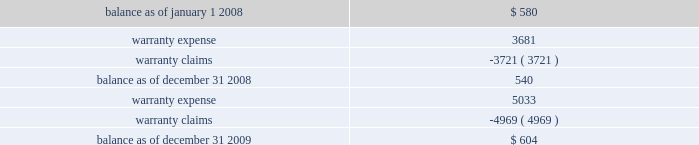Investments prior to our acquisition of keystone on october 12 , 2007 , we held common shares of keystone , which were classified as an available-for-sale investment security .
Accordingly , the investment was included in other assets at its fair value , with the unrealized gain excluded from earnings and included in accumulated other comprehensive income , net of applicable taxes .
Upon our acquisition of keystone on october 12 , 2007 , the unrealized gain was removed from accumulated other comprehensive income , net of applicable taxes , and the original cost of the common shares was considered a component of the purchase price .
Fair value of financial instruments our debt is reflected on the balance sheet at cost .
Based on current market conditions , our interest rate margins are below the rate available in the market , which causes the fair value of our debt to fall below the carrying value .
The fair value of our term loans ( see note 6 , 201clong-term obligations 201d ) is approximately $ 570 million at december 31 , 2009 , as compared to the carrying value of $ 596 million .
We estimated the fair value of our term loans by calculating the upfront cash payment a market participant would require to assume our obligations .
The upfront cash payment , excluding any issuance costs , is the amount that a market participant would be able to lend at december 31 , 2009 to an entity with a credit rating similar to ours and achieve sufficient cash inflows to cover the scheduled cash outflows under our term loans .
The carrying amounts of our cash and equivalents , net trade receivables and accounts payable approximate fair value .
We apply the market approach to value our financial assets and liabilities , which include the cash surrender value of life insurance , deferred compensation liabilities and interest rate swaps .
The market approach utilizes available market information to estimate fair value .
Required fair value disclosures are included in note 8 , 201cfair value measurements . 201d accrued expenses we self-insure a portion of employee medical benefits under the terms of our employee health insurance program .
We purchase certain stop-loss insurance to limit our liability exposure .
We also self-insure a portion of our property and casualty risk , which includes automobile liability , general liability , workers 2019 compensation and property under deductible insurance programs .
The insurance premium costs are expensed over the contract periods .
A reserve for liabilities associated with these losses is established for claims filed and claims incurred but not yet reported based upon our estimate of ultimate cost , which is calculated using analyses of historical data .
We monitor new claims and claim development as well as trends related to the claims incurred but not reported in order to assess the adequacy of our insurance reserves .
Self-insurance reserves on the consolidated balance sheets are net of claims deposits of $ 0.7 million and $ 0.8 million , at december 31 , 2009 and 2008 , respectively .
While we do not expect the amounts ultimately paid to differ significantly from our estimates , our insurance reserves and corresponding expenses could be affected if future claim experience differs significantly from historical trends and assumptions .
Product warranties some of our mechanical products are sold with a standard six-month warranty against defects .
We record the estimated warranty costs at the time of sale using historical warranty claim information to project future warranty claims activity and related expenses .
The changes in the warranty reserve are as follows ( in thousands ) : .

Based on the review of the changes in the warranty reserve what was the percentage change in the year end balance in 2009? 
Computations: ((604 - 540) / 540)
Answer: 0.11852. 